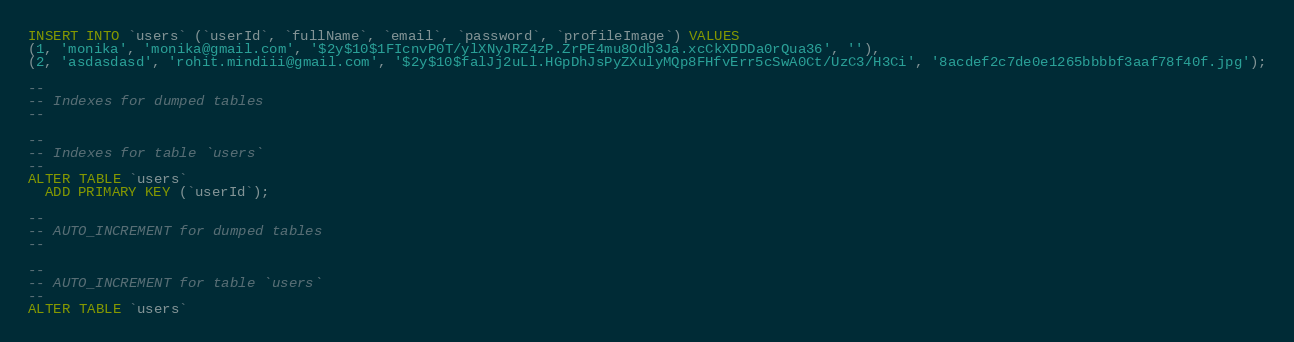Convert code to text. <code><loc_0><loc_0><loc_500><loc_500><_SQL_>INSERT INTO `users` (`userId`, `fullName`, `email`, `password`, `profileImage`) VALUES
(1, 'monika', 'monika@gmail.com', '$2y$10$1FIcnvP0T/ylXNyJRZ4zP.ZrPE4mu8Odb3Ja.xcCkXDDDa0rQua36', ''),
(2, 'asdasdasd', 'rohit.mindiii@gmail.com', '$2y$10$falJj2uLl.HGpDhJsPyZXulyMQp8FHfvErr5cSwA0Ct/UzC3/H3Ci', '8acdef2c7de0e1265bbbbf3aaf78f40f.jpg');

--
-- Indexes for dumped tables
--

--
-- Indexes for table `users`
--
ALTER TABLE `users`
  ADD PRIMARY KEY (`userId`);

--
-- AUTO_INCREMENT for dumped tables
--

--
-- AUTO_INCREMENT for table `users`
--
ALTER TABLE `users`</code> 